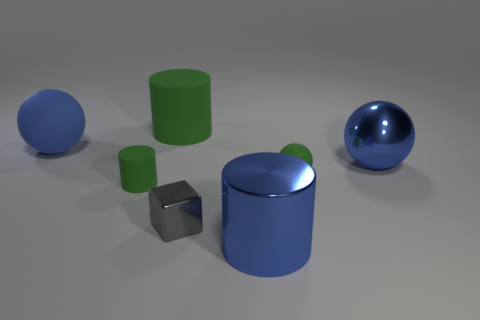Subtract all big cylinders. How many cylinders are left? 1 Subtract all spheres. How many objects are left? 4 Add 2 blue matte spheres. How many objects exist? 9 Subtract 3 spheres. How many spheres are left? 0 Subtract all blue blocks. Subtract all purple cylinders. How many blocks are left? 1 Subtract all purple blocks. How many blue cylinders are left? 1 Subtract all large gray rubber blocks. Subtract all big blue things. How many objects are left? 4 Add 2 tiny things. How many tiny things are left? 5 Add 6 blue spheres. How many blue spheres exist? 8 Subtract all blue spheres. How many spheres are left? 1 